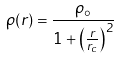Convert formula to latex. <formula><loc_0><loc_0><loc_500><loc_500>\rho ( r ) = \frac { \rho _ { \circ } } { 1 + \left ( \frac { r } { r _ { c } } \right ) ^ { 2 } } \,</formula> 